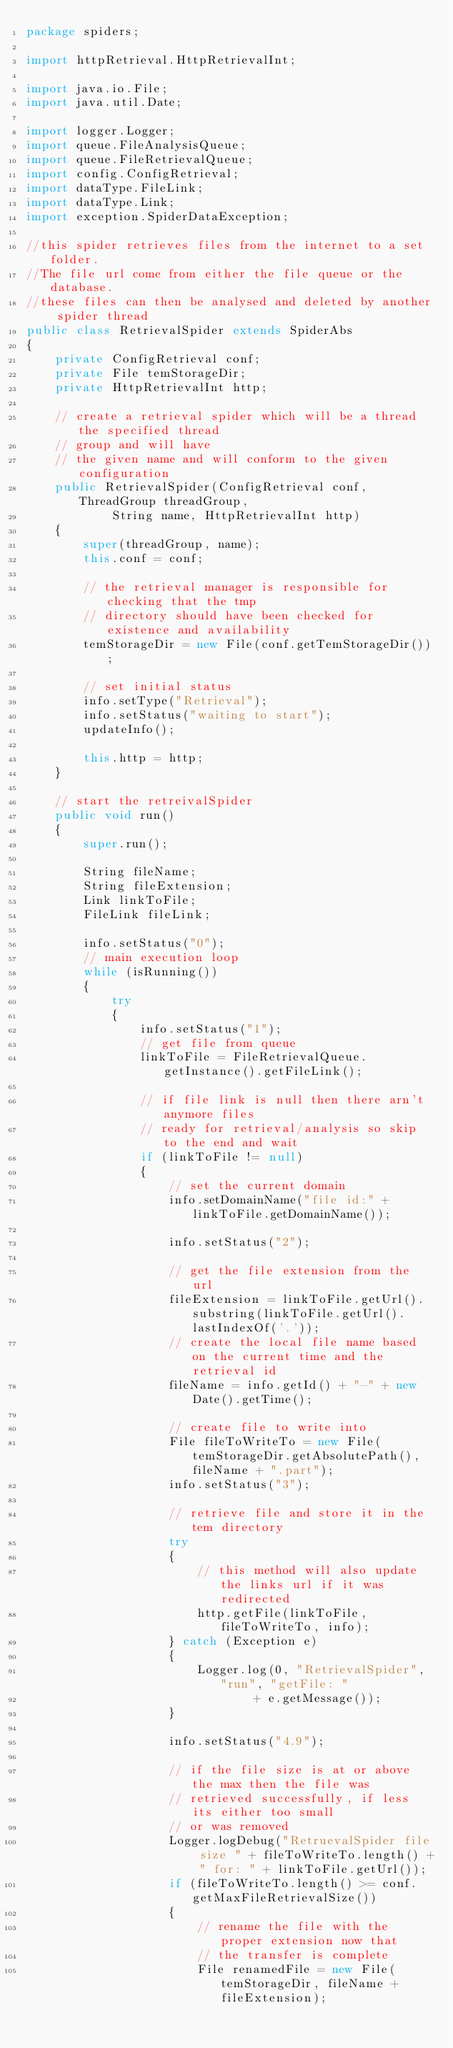Convert code to text. <code><loc_0><loc_0><loc_500><loc_500><_Java_>package spiders;

import httpRetrieval.HttpRetrievalInt;

import java.io.File;
import java.util.Date;

import logger.Logger;
import queue.FileAnalysisQueue;
import queue.FileRetrievalQueue;
import config.ConfigRetrieval;
import dataType.FileLink;
import dataType.Link;
import exception.SpiderDataException;

//this spider retrieves files from the internet to a set folder.
//The file url come from either the file queue or the database.
//these files can then be analysed and deleted by another spider thread
public class RetrievalSpider extends SpiderAbs
{
	private ConfigRetrieval conf;
	private File temStorageDir;
	private HttpRetrievalInt http;

	// create a retrieval spider which will be a thread the specified thread
	// group and will have
	// the given name and will conform to the given configuration
	public RetrievalSpider(ConfigRetrieval conf, ThreadGroup threadGroup,
			String name, HttpRetrievalInt http)
	{
		super(threadGroup, name);
		this.conf = conf;

		// the retrieval manager is responsible for checking that the tmp
		// directory should have been checked for existence and availability
		temStorageDir = new File(conf.getTemStorageDir());

		// set initial status
		info.setType("Retrieval");
		info.setStatus("waiting to start");
		updateInfo();

		this.http = http;
	}

	// start the retreivalSpider
	public void run()
	{
		super.run();
		
		String fileName;
		String fileExtension;
		Link linkToFile;
		FileLink fileLink; 
		
		info.setStatus("0");
		// main execution loop
		while (isRunning())
		{
			try
			{
				info.setStatus("1");
				// get file from queue
				linkToFile = FileRetrievalQueue.getInstance().getFileLink();

				// if file link is null then there arn't anymore files
				// ready for retrieval/analysis so skip to the end and wait
				if (linkToFile != null)
				{
					// set the current domain
					info.setDomainName("file id:" + linkToFile.getDomainName());

					info.setStatus("2");

					// get the file extension from the url
					fileExtension = linkToFile.getUrl().substring(linkToFile.getUrl().lastIndexOf('.'));
					// create the local file name based on the current time and the retrieval id
					fileName = info.getId() + "-" + new Date().getTime();
					
					// create file to write into
					File fileToWriteTo = new File(temStorageDir.getAbsolutePath(), fileName + ".part");
					info.setStatus("3");

					// retrieve file and store it in the tem directory
					try
					{
						// this method will also update the links url if it was redirected
						http.getFile(linkToFile, fileToWriteTo, info);
					} catch (Exception e)
					{
						Logger.log(0, "RetrievalSpider", "run", "getFile: "
								+ e.getMessage());
					}

					info.setStatus("4.9");

					// if the file size is at or above the max then the file was
					// retrieved successfully, if less its either too small
					// or was removed
					Logger.logDebug("RetruevalSpider file size " + fileToWriteTo.length() + " for: " + linkToFile.getUrl());
					if (fileToWriteTo.length() >= conf.getMaxFileRetrievalSize())
					{
						// rename the file with the proper extension now that
						// the transfer is complete
						File renamedFile = new File(temStorageDir, fileName + fileExtension);</code> 